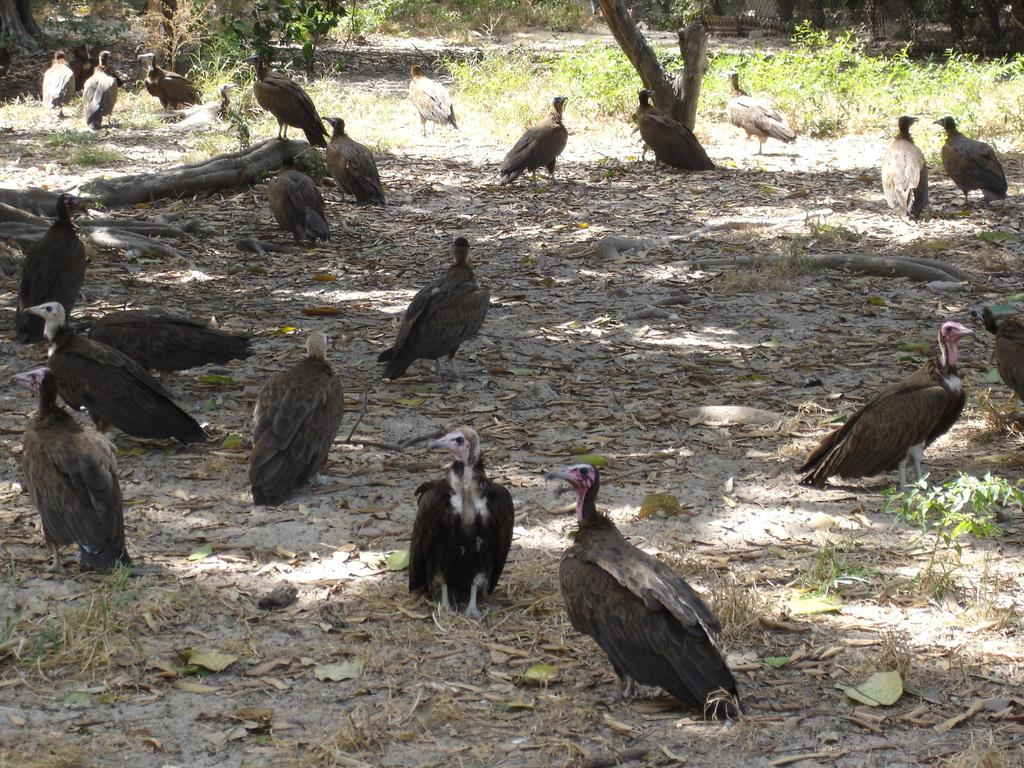What type of animals can be seen on the ground in the image? There are many birds on the ground in the image. What else can be found on the ground in the image? Dry leaves are present in the image. What type of vegetation is visible in the image? Small plants are visible in the image. What can be seen in the background of the image? There are trees and a fence in the background of the image. What type of word is being baked in the oven in the image? There is no oven or word present in the image. 